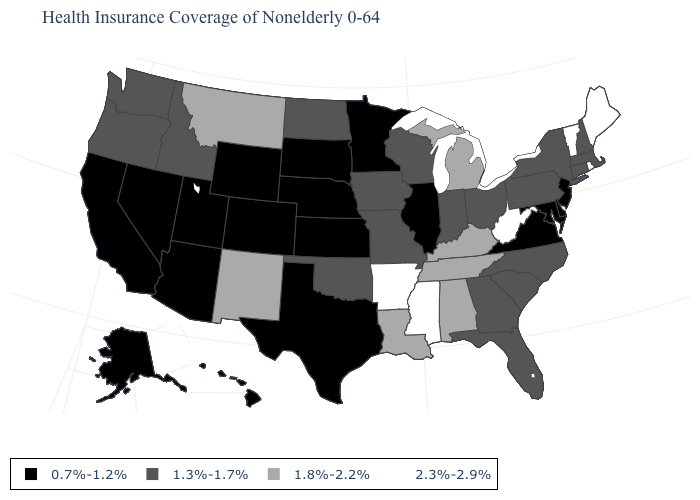Name the states that have a value in the range 0.7%-1.2%?
Short answer required. Alaska, Arizona, California, Colorado, Delaware, Hawaii, Illinois, Kansas, Maryland, Minnesota, Nebraska, Nevada, New Jersey, South Dakota, Texas, Utah, Virginia, Wyoming. Name the states that have a value in the range 1.3%-1.7%?
Keep it brief. Connecticut, Florida, Georgia, Idaho, Indiana, Iowa, Massachusetts, Missouri, New Hampshire, New York, North Carolina, North Dakota, Ohio, Oklahoma, Oregon, Pennsylvania, South Carolina, Washington, Wisconsin. What is the value of Pennsylvania?
Write a very short answer. 1.3%-1.7%. Name the states that have a value in the range 2.3%-2.9%?
Write a very short answer. Arkansas, Maine, Mississippi, Rhode Island, Vermont, West Virginia. What is the lowest value in the USA?
Be succinct. 0.7%-1.2%. What is the highest value in the South ?
Quick response, please. 2.3%-2.9%. Among the states that border Arizona , does New Mexico have the lowest value?
Give a very brief answer. No. How many symbols are there in the legend?
Write a very short answer. 4. What is the value of Kentucky?
Keep it brief. 1.8%-2.2%. What is the highest value in the South ?
Concise answer only. 2.3%-2.9%. Does the map have missing data?
Give a very brief answer. No. Which states have the lowest value in the USA?
Keep it brief. Alaska, Arizona, California, Colorado, Delaware, Hawaii, Illinois, Kansas, Maryland, Minnesota, Nebraska, Nevada, New Jersey, South Dakota, Texas, Utah, Virginia, Wyoming. Does the map have missing data?
Be succinct. No. What is the lowest value in the USA?
Be succinct. 0.7%-1.2%. Among the states that border Wyoming , does Montana have the lowest value?
Be succinct. No. 